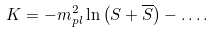Convert formula to latex. <formula><loc_0><loc_0><loc_500><loc_500>K = - m ^ { 2 } _ { p l } \ln \left ( S + \overline { S } \right ) - \dots .</formula> 